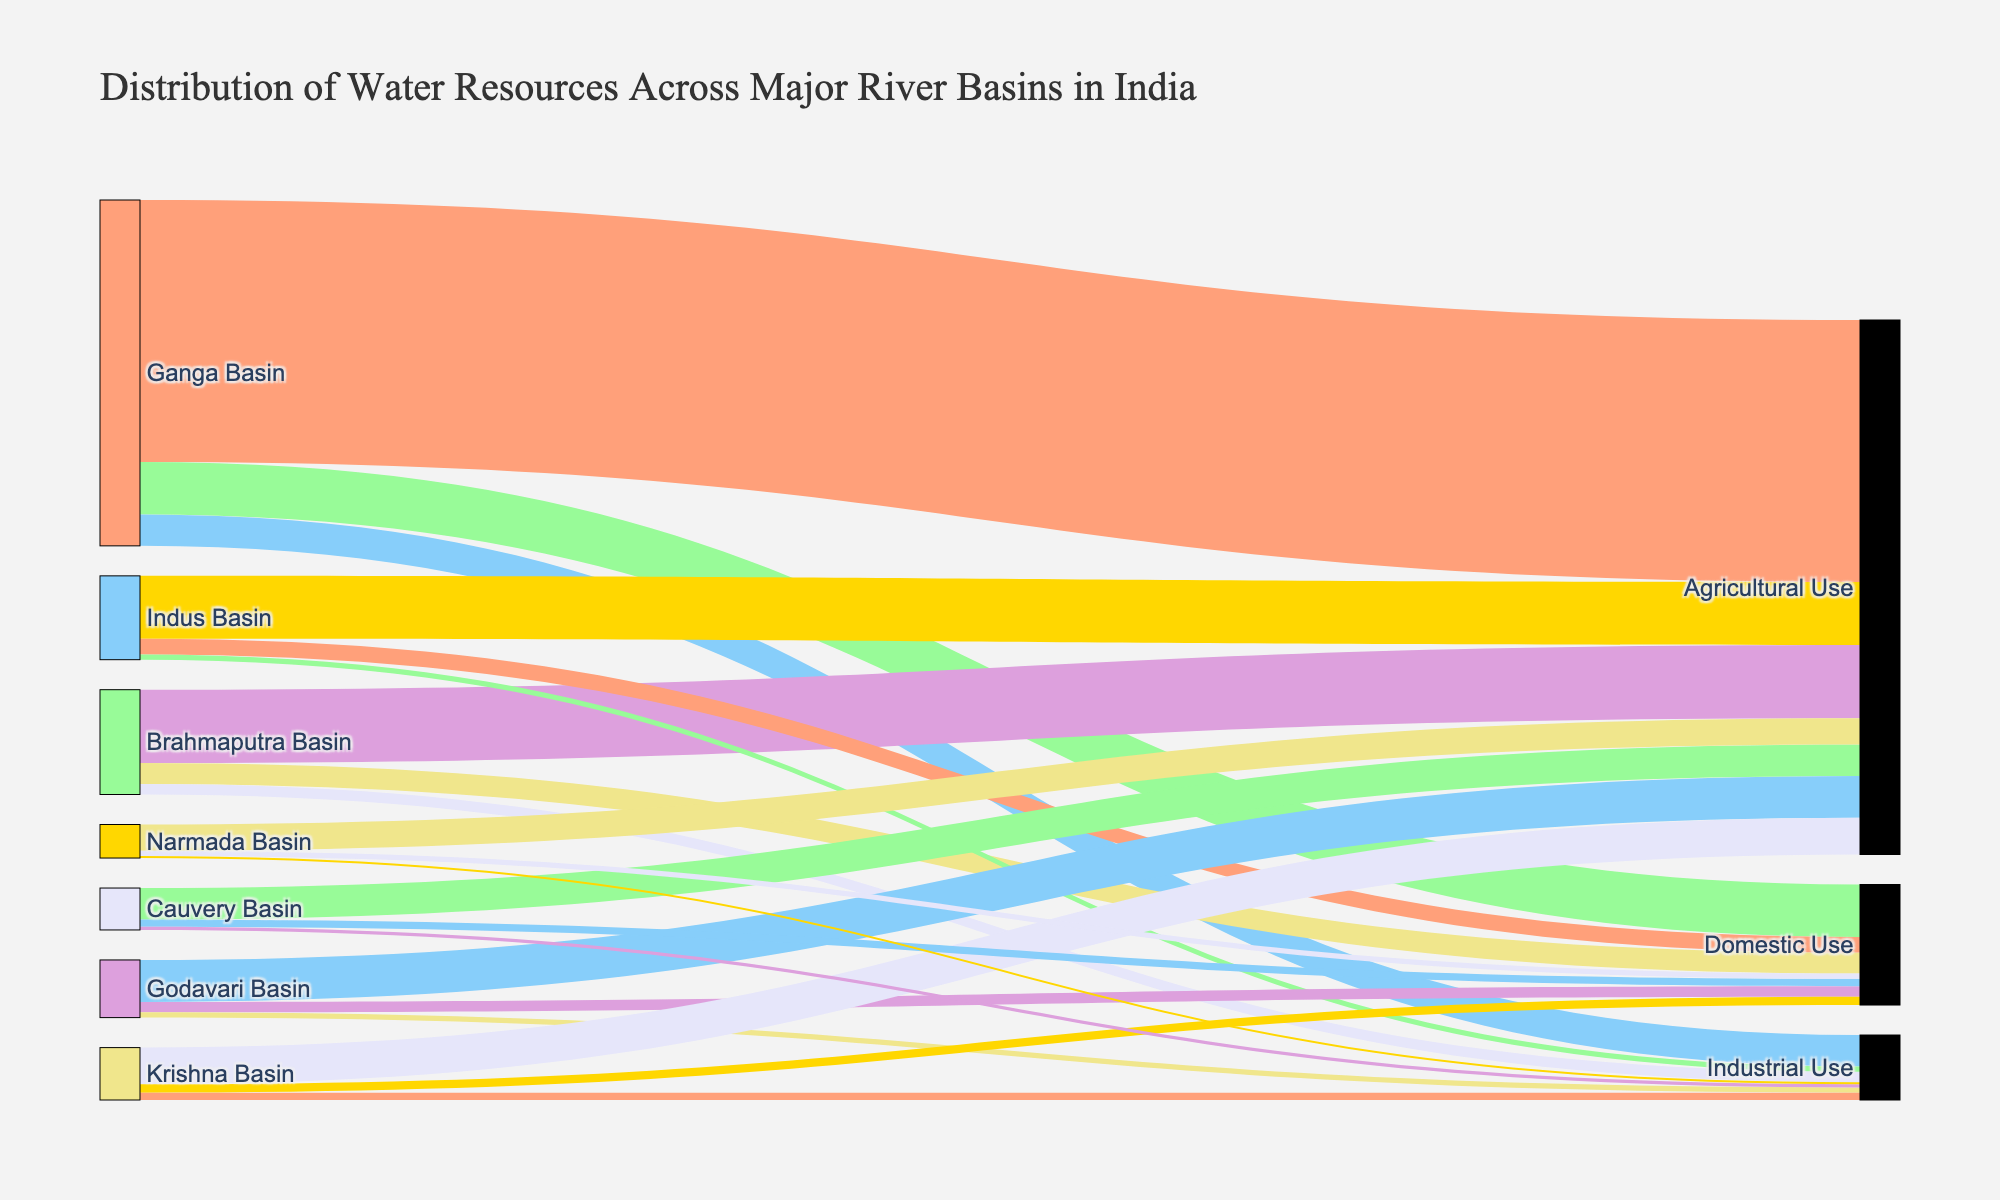What's the total amount of water used for agricultural purposes across all river basins? To find the total agricultural use, sum the values from all basins: Ganga (250) + Brahmaputra (70) + Indus (60) + Godavari (40) + Krishna (35) + Cauvery (30) + Narmada (25) = 510.
Answer: 510 Which river basin distributes the highest amount of water for industrial use? Compare the industrial use values for each basin: Ganga (30), Brahmaputra (10), Indus (5), Godavari (5), Krishna (7), Cauvery (3), Narmada (2). The Ganga Basin has the highest industrial use with 30 units.
Answer: Ganga Basin How much more water does the Ganga Basin use for agricultural purposes compared to the Krishna Basin? Subtract the agricultural use of Krishna Basin from Ganga Basin: 250 (Ganga) - 35 (Krishna) = 215.
Answer: 215 What's the total amount of water distributed by the Godavari Basin across all uses? Add the values for agricultural, domestic, and industrial use in the Godavari Basin: 40 (Agricultural) + 10 (Domestic) + 5 (Industrial) = 55.
Answer: 55 Which basin has the least total water distribution, and how much is it? Sum the values for all uses in each basin: Ganga (330), Brahmaputra (100), Indus (80), Godavari (55), Krishna (50), Cauvery (40), Narmada (32). The Narmada Basin has the least total water distribution with 32 units.
Answer: Narmada Basin, 32 How much more water is used for domestic purposes in the Ganga Basin compared to the Indus Basin? Subtract the domestic use of Indus Basin from Ganga Basin: 50 (Ganga) - 15 (Indus) = 35.
Answer: 35 Which basin has the highest total water distribution, and what is the total amount? Sum the values for all uses in each basin: Ganga (330), Brahmaputra (100), Indus (80), Godavari (55), Krishna (50), Cauvery (40), Narmada (32). The Ganga Basin has the highest total water distribution with 330 units.
Answer: Ganga Basin, 330 What percentage of the Ganga Basin's total water distribution is used for domestic purposes? Calculate the percentage: (Domestic use / Total use) * 100 = (50 / 330) * 100 ≈ 15.15%.
Answer: ≈ 15.15% How does the water used for industrial purposes in the Ganga Basin compare to the combined industrial use of the Indus and Krishna Basins? Compare the values: Ganga (30), Indus (5) + Krishna (7) = 12. Ganga Basin uses 18 units more than the combined industrial use of the Indus and Krishna Basins.
Answer: 18 units more 